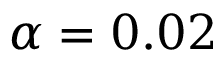Convert formula to latex. <formula><loc_0><loc_0><loc_500><loc_500>\alpha = 0 . 0 2</formula> 